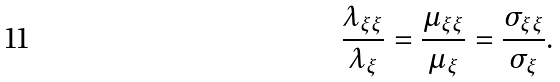<formula> <loc_0><loc_0><loc_500><loc_500>\frac { \lambda _ { \xi \xi } } { \lambda _ { \xi } } = \frac { \mu _ { \xi \xi } } { \mu _ { \xi } } = \frac { \sigma _ { \xi \xi } } { \sigma _ { \xi } } .</formula> 